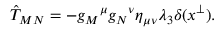<formula> <loc_0><loc_0><loc_500><loc_500>\hat { T } _ { M N } = - g _ { M ^ { \mu } g _ { N ^ { \nu } \eta _ { \mu \nu } \lambda _ { 3 } \delta ( x ^ { \perp } ) .</formula> 